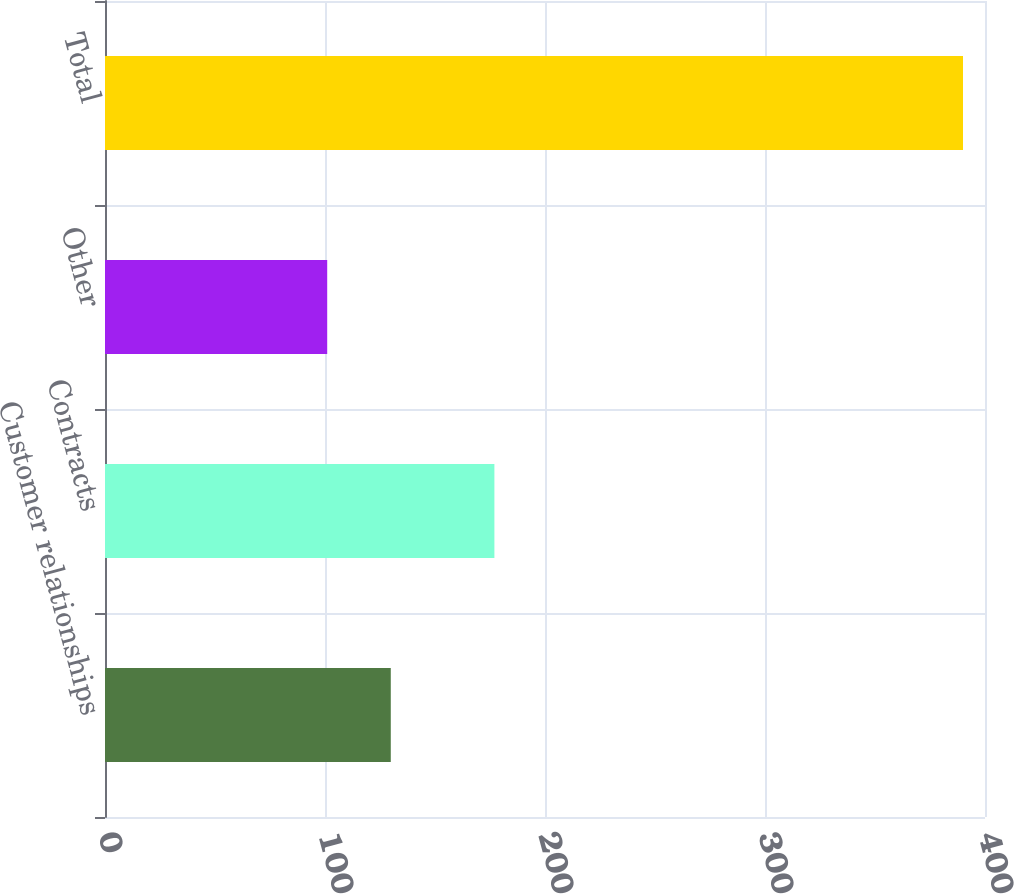Convert chart to OTSL. <chart><loc_0><loc_0><loc_500><loc_500><bar_chart><fcel>Customer relationships<fcel>Contracts<fcel>Other<fcel>Total<nl><fcel>129.9<fcel>177<fcel>101<fcel>390<nl></chart> 